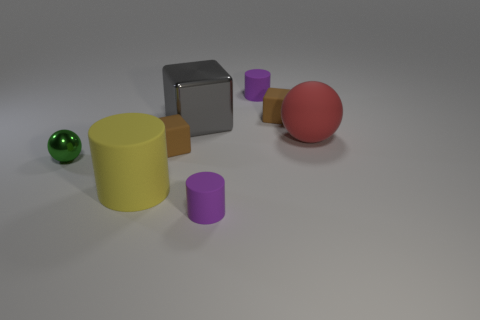There is another thing that is the same shape as the big red rubber thing; what material is it?
Give a very brief answer. Metal. What number of blue objects are either rubber things or blocks?
Ensure brevity in your answer.  0. Is there any other thing of the same color as the big ball?
Give a very brief answer. No. There is a rubber object on the right side of the small brown object behind the matte ball; what color is it?
Offer a terse response. Red. Are there fewer cylinders behind the big gray metal object than red things behind the red matte sphere?
Keep it short and to the point. No. How many things are either large things that are in front of the gray block or green metal cubes?
Offer a terse response. 2. Is the size of the matte cube on the right side of the gray shiny object the same as the red ball?
Give a very brief answer. No. Are there fewer small metal spheres in front of the green thing than tiny brown matte cubes?
Offer a very short reply. Yes. There is a yellow object that is the same size as the red object; what is it made of?
Provide a short and direct response. Rubber. How many tiny things are either spheres or yellow cylinders?
Offer a terse response. 1. 